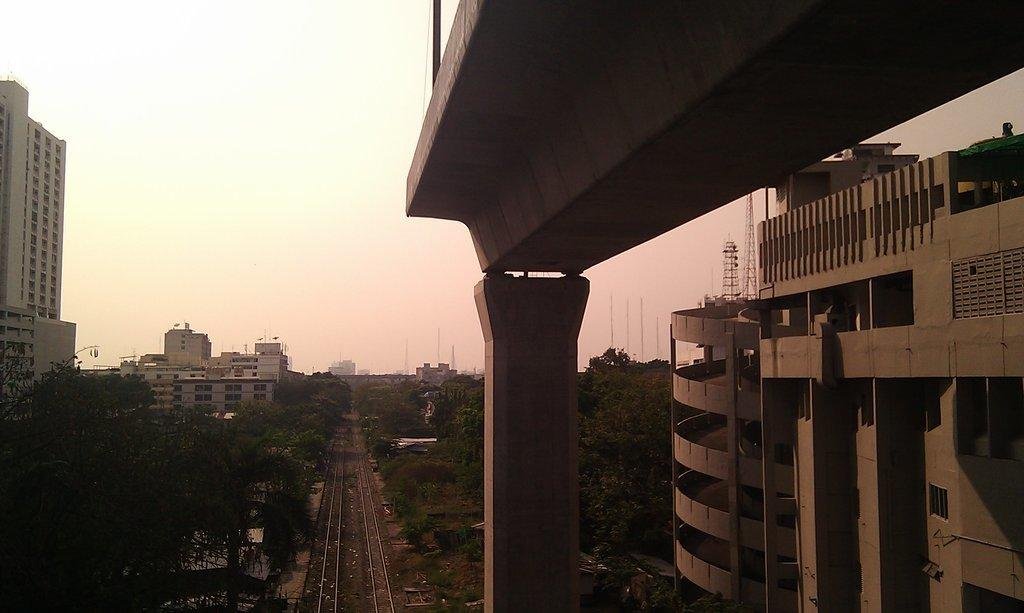What type of view is provided in the image? The image is a top view. What type of structure can be seen in the image? There is a tower building in the image. What architectural element is present in the image? There is a pillar in the image. What type of transportation infrastructure is visible in the image? There is a metro bridge in the image. What type of vegetation is present in the image? There are trees in the image. What is visible in the background of the image? The sky is visible in the background of the image. Can you hear the snake playing chess in the image? There is no snake or chess game present in the image, and therefore no such activity can be heard. 